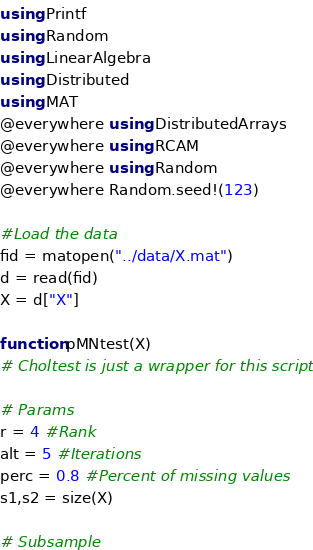<code> <loc_0><loc_0><loc_500><loc_500><_Julia_>using Printf
using Random
using LinearAlgebra
using Distributed
using MAT
@everywhere using DistributedArrays
@everywhere using RCAM
@everywhere using Random
@everywhere Random.seed!(123)

#Load the data
fid = matopen("../data/X.mat")
d = read(fid)
X = d["X"]

function pMNtest(X)
# Choltest is just a wrapper for this script

# Params
r = 4 #Rank
alt = 5 #Iterations
perc = 0.8 #Percent of missing values
s1,s2 = size(X)

# Subsample</code> 